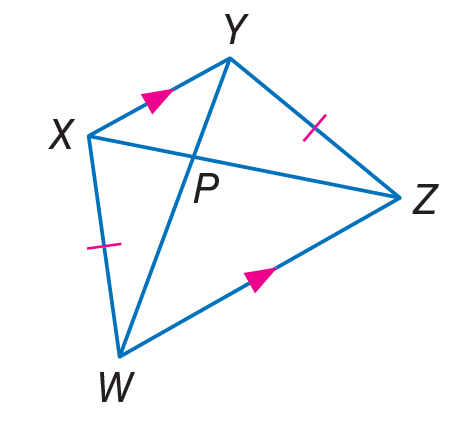Answer the mathemtical geometry problem and directly provide the correct option letter.
Question: Find P W, if X Z = 18 and P Y = 3.
Choices: A: 3 B: 6 C: 15 D: 18 C 